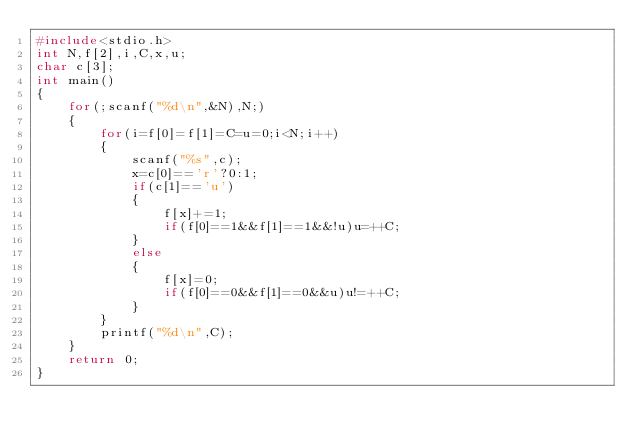<code> <loc_0><loc_0><loc_500><loc_500><_C_>#include<stdio.h>
int N,f[2],i,C,x,u;
char c[3];
int main()
{
	for(;scanf("%d\n",&N),N;)
	{
		for(i=f[0]=f[1]=C=u=0;i<N;i++)
		{
			scanf("%s",c);
			x=c[0]=='r'?0:1;
			if(c[1]=='u')
			{
				f[x]+=1;
				if(f[0]==1&&f[1]==1&&!u)u=++C;
			}
			else
			{
				f[x]=0;
				if(f[0]==0&&f[1]==0&&u)u!=++C;
			}
		}
		printf("%d\n",C);
	}
	return 0;
}</code> 